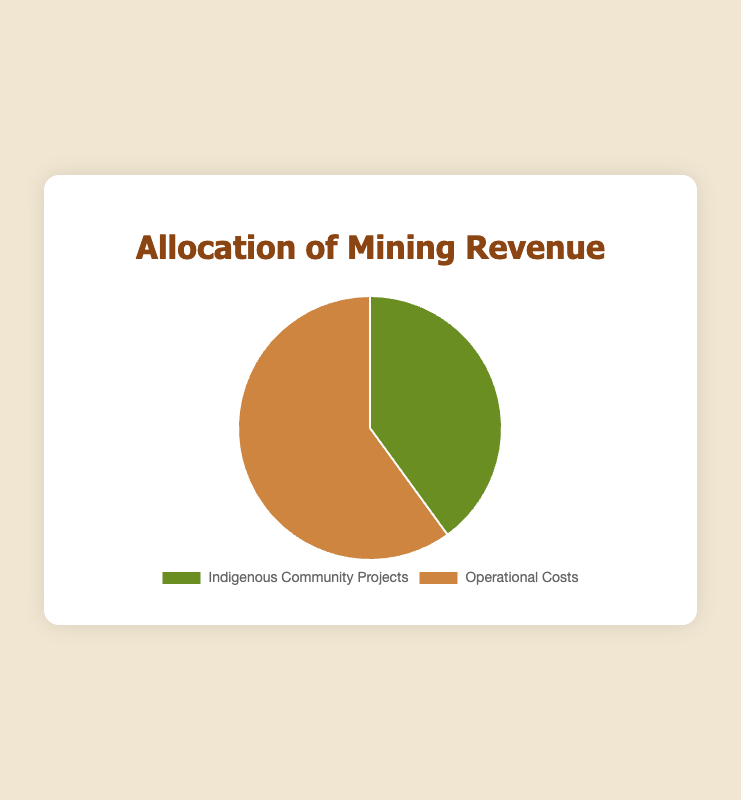How much revenue is allocated to Indigenous Community Projects? The slice labeled 'Indigenous Community Projects' represents 40% of the total mining revenue, as clearly indicated in the pie chart.
Answer: 40% How much revenue is allocated to Operational Costs? The slice labeled 'Operational Costs' represents 60% of the total mining revenue, as clearly indicated in the pie chart.
Answer: 60% Which allocation receives a higher percentage of the mining revenue? By comparing the two slices in the pie chart, 'Operational Costs' receives a higher percentage at 60%, compared to 'Indigenous Community Projects' at 40%.
Answer: Operational Costs Is the allocation for Operational Costs more than twice the allocation for Indigenous Community Projects? The percentage for Operational Costs is 60%, and double the allocation for Indigenous Community Projects (40%) is 80%. Since 60% is less than 80%, Operational Costs is not more than twice the allocation for Indigenous Community Projects.
Answer: No If the total mining revenue is $1,000,000, how much is allocated to Indigenous Community Projects? Since 40% of the total revenue is allocated to Indigenous Community Projects, $1,000,000 * 0.40 = $400,000 is allocated to Indigenous Community Projects.
Answer: $400,000 If the total mining revenue is $1,000,000, how much is allocated to Operational Costs? Since 60% of the total revenue is allocated to Operational Costs, $1,000,000 * 0.60 = $600,000 is allocated to Operational Costs.
Answer: $600,000 What is the combined percentage allocation for both Indigenous Community Projects and Operational Costs? By summing the two percentages: 40% for Indigenous Community Projects + 60% for Operational Costs, the combined allocation is 100%.
Answer: 100% How many times greater is the allocation for Operational Costs compared to Indigenous Community Projects? The allocation for Operational Costs (60%) divided by the allocation for Indigenous Community Projects (40%) gives 60 / 40 = 1.5 times greater.
Answer: 1.5 What are the colors used to differentiate the allocations in the pie chart? The slice for 'Indigenous Community Projects' is shaded green, and the slice for 'Operational Costs' is shaded brown.
Answer: Green and Brown 